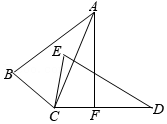First perform reasoning, then finally select the question from the choices in the following format: Answer: xxx.
Question: In the given diagram, triangle ABC is congruent to triangle DEC, with corresponding vertices A and D, and B and E. A perpendicular line AF is drawn through point A, intersecting CD at point F. If angle BCE is represented by the variable 'x' (x = 60°), what is the measure of angle CAF? Express the angle as 'y' in terms of 'x'.
Choices:
A: 35°
B: 30°
C: 60°
D: 65° To find the measure of angle CAF, we can use the fact that triangle ABC is congruent to triangle DEC. This implies that angle DCE is equal to angle ACB. By subtracting angle ACE from both sides of the equation, we have angle ACD = angle BCE. Given that angle BCE is equal to 60° (represented by 'x'), we can substitute it into the equation to get angle ACD = 60°. Since AF is perpendicular to CD, angle AFC is 90°. Therefore, angle CAF is equal to 90° minus angle ACD, which is 90° - 60° = 30°. Therefore, the measure of angle CAF is 30°. Hence, the answer is option B.
Answer:B 